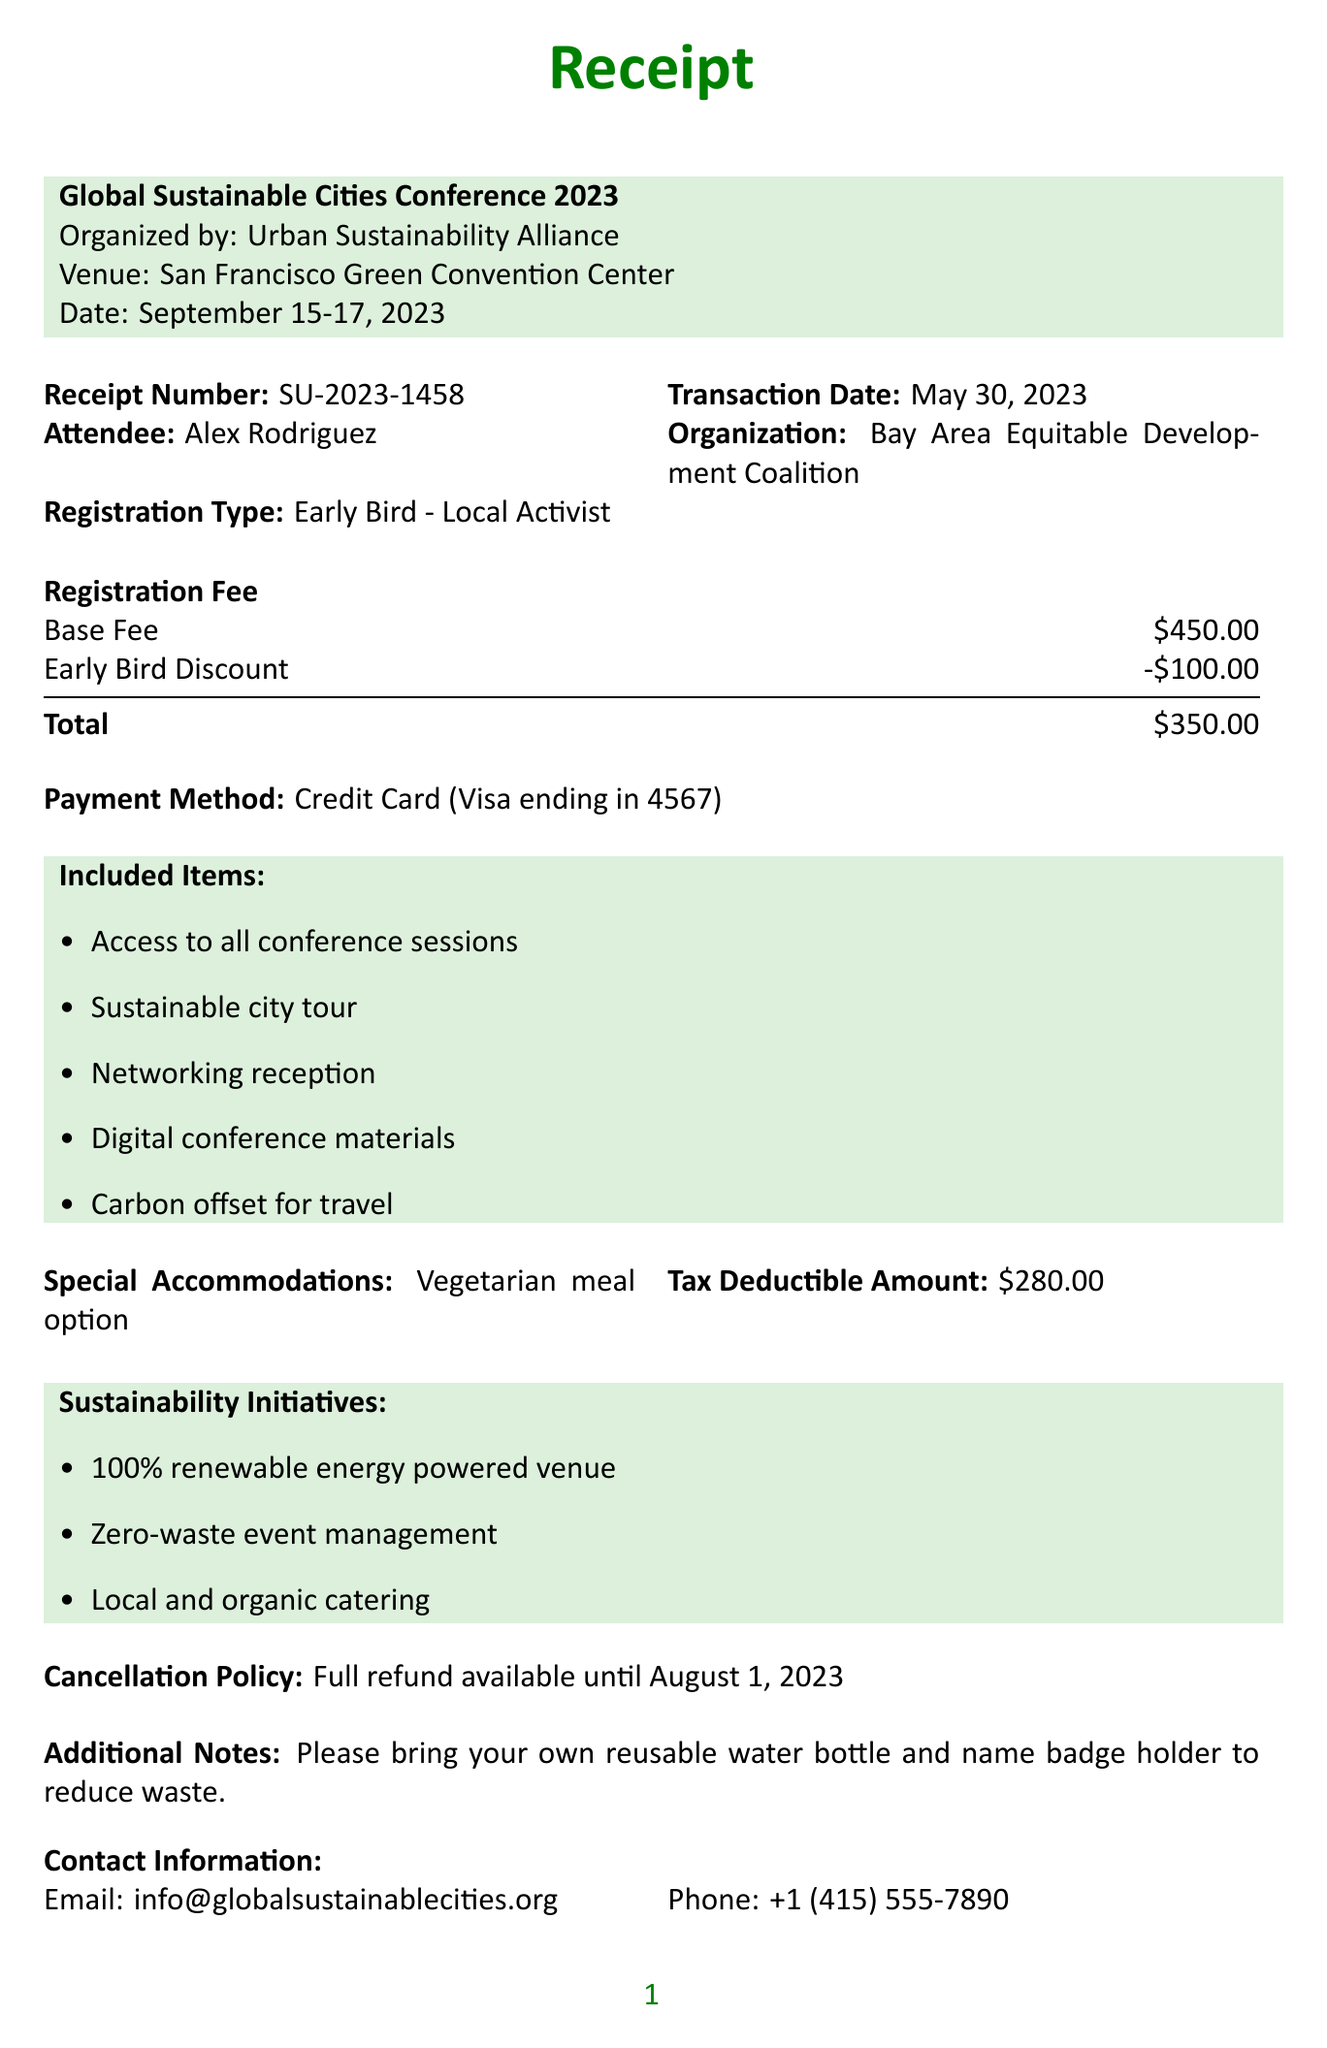What is the receipt number? The receipt number is a unique identifier for this transaction, which is printed on the document.
Answer: SU-2023-1458 What is the total registration fee? The total registration fee is calculated by taking the base fee and applying the early bird discount, as shown in the document.
Answer: $350.00 When is the conference date? The conference date specifies when the event will take place, listed clearly in the document.
Answer: September 15-17, 2023 Who organized the conference? The organizer is mentioned directly in the document, providing information about who coordinated the event.
Answer: Urban Sustainability Alliance What items are included in the registration? This question pertains to the list of benefits attendees receive, which is specified in the included items section.
Answer: Access to all conference sessions, Sustainable city tour, Networking reception, Digital conference materials, Carbon offset for travel What is the cancellation policy? The cancellation policy outlines the options available to attendees for refunds, which is described in a specific section of the document.
Answer: Full refund available until August 1, 2023 What type of meal option is provided? This question specifically refers to dietary accommodations mentioned in the document that the organizer provides for attendees.
Answer: Vegetarian meal option Which sustainability initiatives are highlighted? The sustainability initiatives are enumerated benefits regarding eco-friendliness of the event, provided in the document.
Answer: 100% renewable energy powered venue, Zero-waste event management, Local and organic catering What is the tax deductible amount? The tax deductible amount refers to how much of the registration fee can be deducted for tax purposes, specified in the document.
Answer: $280.00 